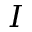Convert formula to latex. <formula><loc_0><loc_0><loc_500><loc_500>I</formula> 